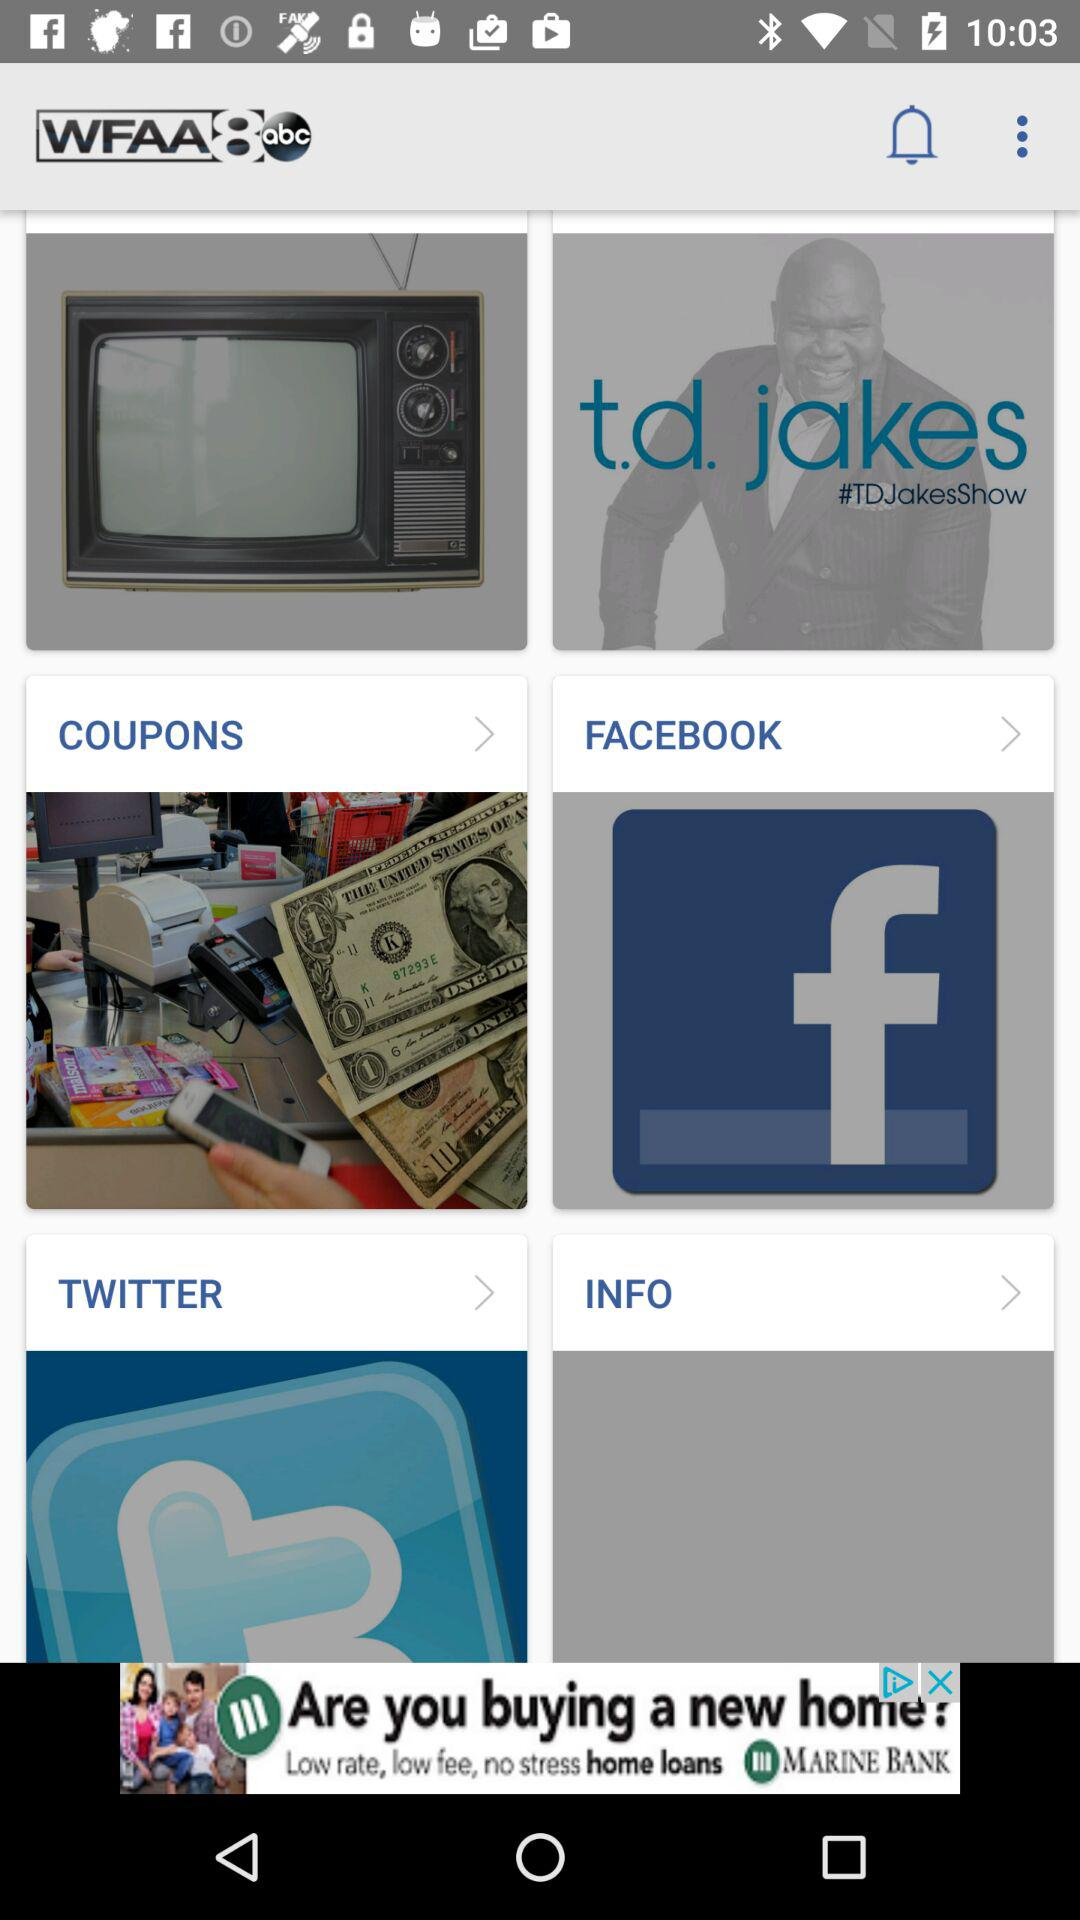What is the name of the application? The application name is "WFAA8abc". 